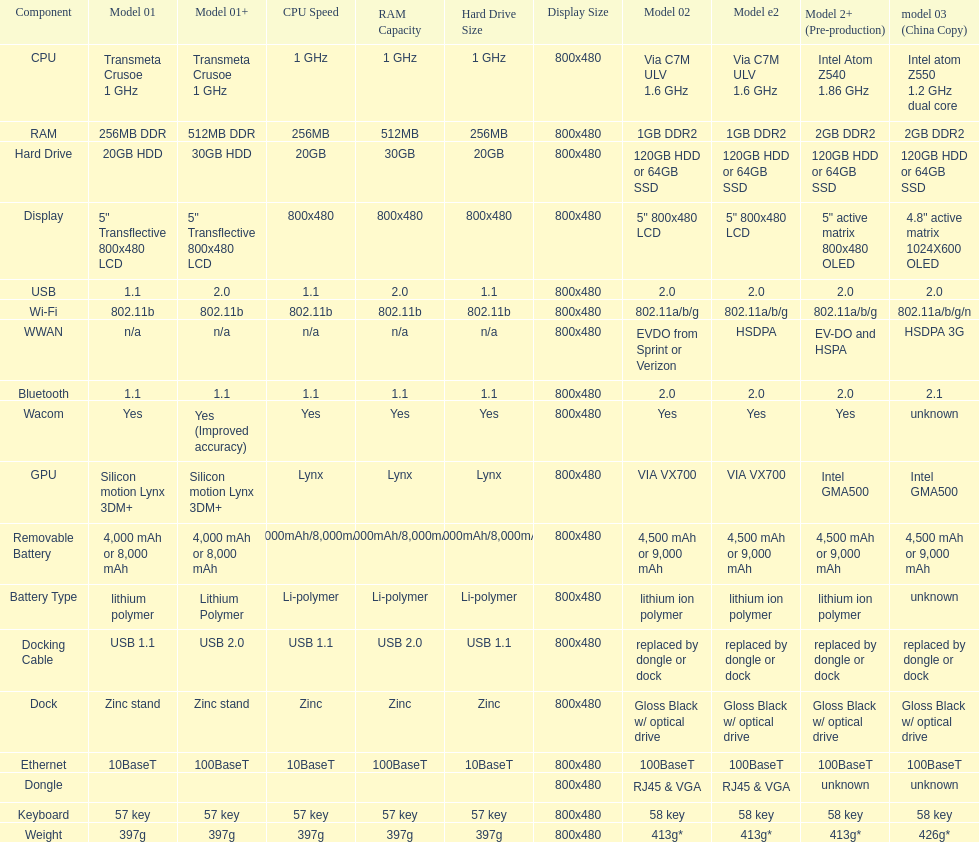How many models employ a usb docking cable? 2. 